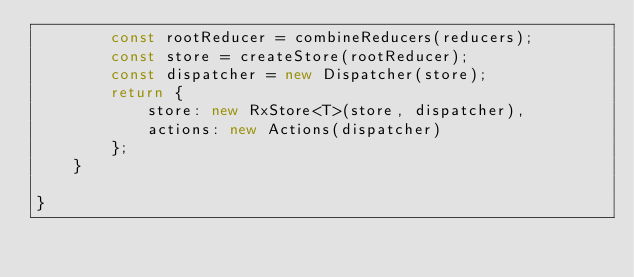<code> <loc_0><loc_0><loc_500><loc_500><_TypeScript_>        const rootReducer = combineReducers(reducers);
        const store = createStore(rootReducer);
        const dispatcher = new Dispatcher(store);
        return {
            store: new RxStore<T>(store, dispatcher),
            actions: new Actions(dispatcher)
        };
    }

}</code> 